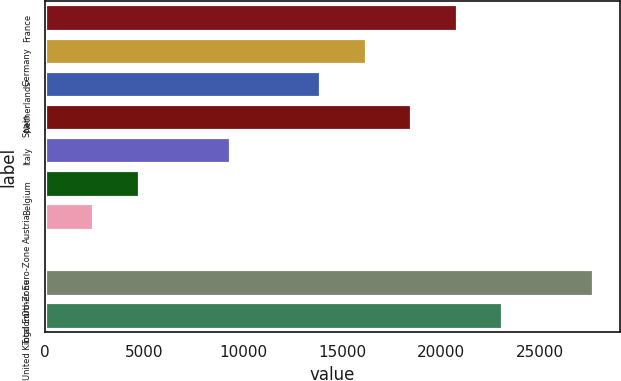Convert chart to OTSL. <chart><loc_0><loc_0><loc_500><loc_500><bar_chart><fcel>France<fcel>Germany<fcel>Netherlands<fcel>Spain<fcel>Italy<fcel>Belgium<fcel>Austria<fcel>Other Euro-Zone<fcel>Total Euro-Zone<fcel>United Kingdom<nl><fcel>20788<fcel>16202<fcel>13909<fcel>18495<fcel>9323<fcel>4737<fcel>2444<fcel>151<fcel>27667<fcel>23081<nl></chart> 